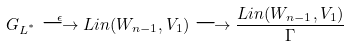Convert formula to latex. <formula><loc_0><loc_0><loc_500><loc_500>G _ { L ^ { ^ { * } } } \stackrel { \epsilon } { \longrightarrow } L i n ( W _ { n - 1 } , V _ { 1 } ) \longrightarrow \frac { L i n ( W _ { n - 1 } , V _ { 1 } ) } { \Gamma }</formula> 